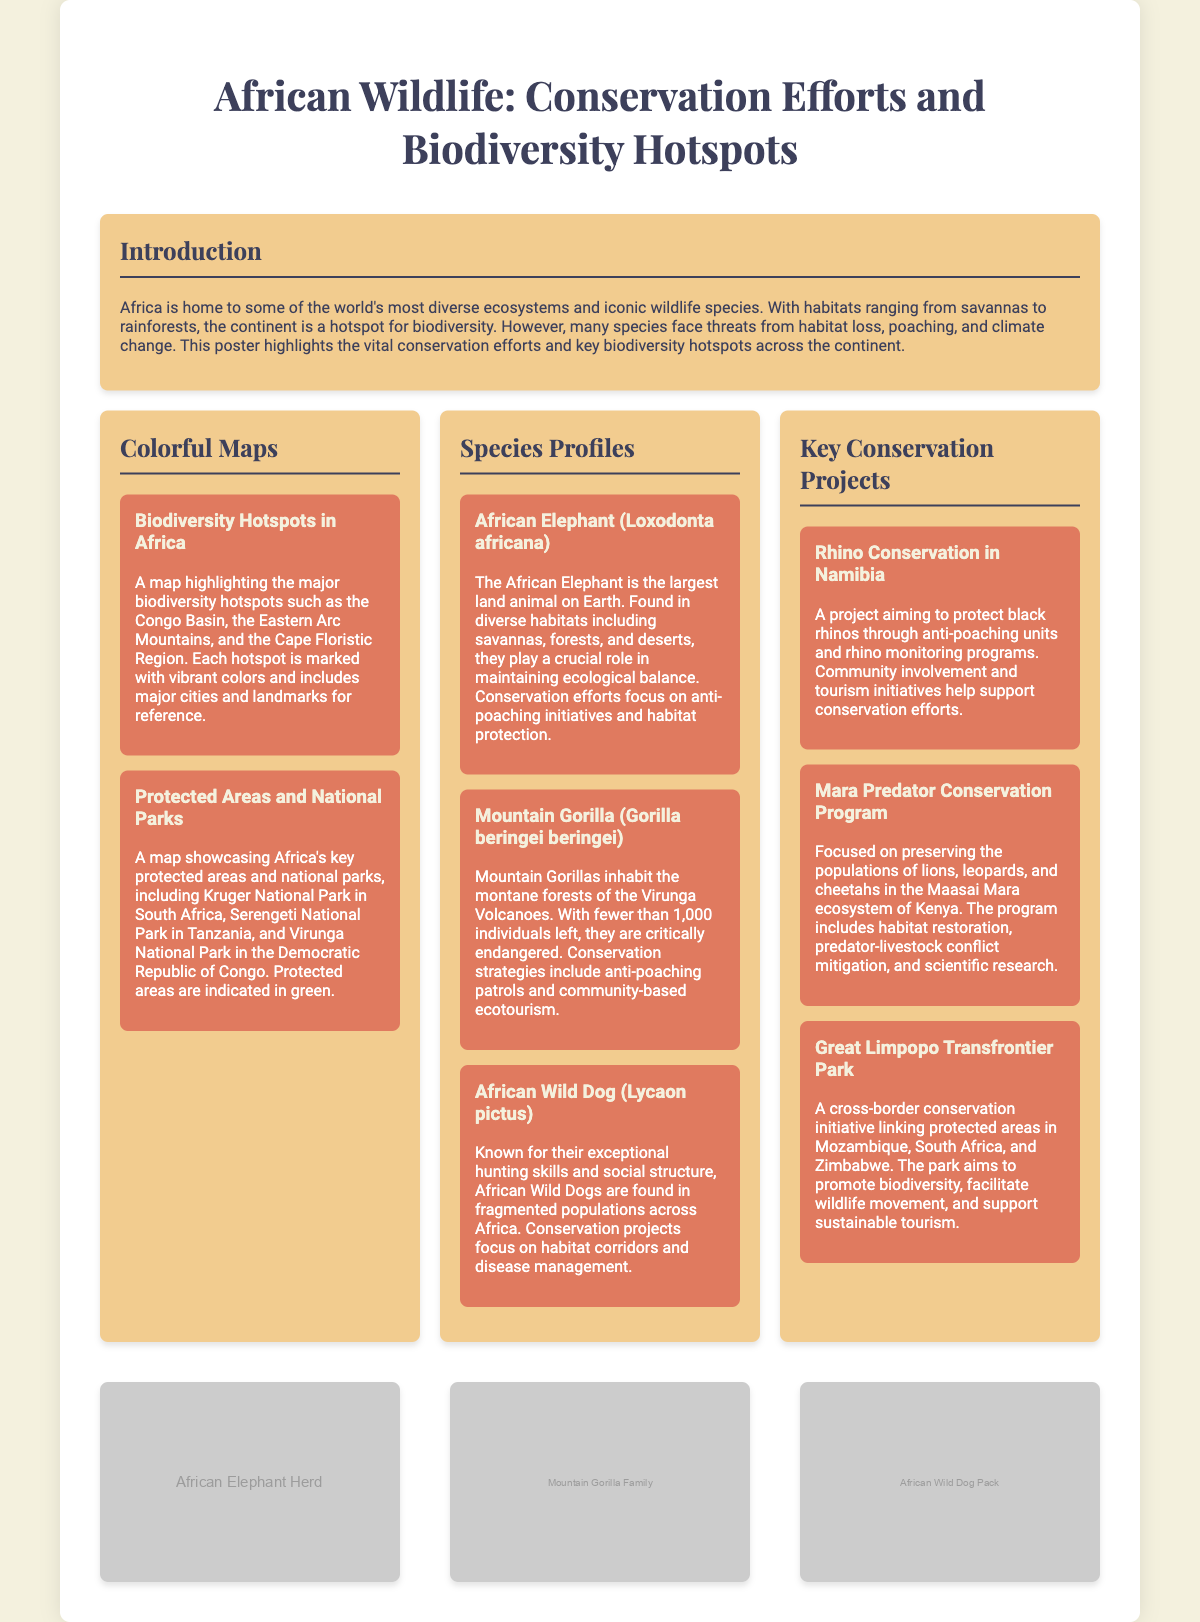What is the title of the poster? The title is prominently displayed at the top of the poster, which is "African Wildlife: Conservation Efforts and Biodiversity Hotspots."
Answer: African Wildlife: Conservation Efforts and Biodiversity Hotspots How many species profiles are featured in the poster? The species profiles section contains three distinct species profiles.
Answer: Three What is the primary threat faced by the African Elephant? The document mentions threats including habitat loss and poaching, specifically highlighting anti-poaching initiatives.
Answer: Poaching Which national park is included in the protected areas map? The protected areas map features several national parks, including Kruger National Park.
Answer: Kruger National Park What conservation project focuses on black rhinos? The document outlines a specific project that aims to protect black rhinos in Namibia.
Answer: Rhino Conservation in Namibia How does the Mara Predator Conservation Program help wildlife? The document indicates that it includes habitat restoration and predator-livestock conflict mitigation.
Answer: Habitat restoration What is a key biodiversity hotspot highlighted in the document? The poster highlights several, including the Congo Basin among others.
Answer: Congo Basin What role do African Wild Dogs play in their ecosystem? The document states they have exceptional hunting skills and maintain social structures.
Answer: Hunting skills Which three countries are linked by the Great Limpopo Transfrontier Park? The project mentions Mozambique, South Africa, and Zimbabwe as connected countries.
Answer: Mozambique, South Africa, Zimbabwe 